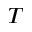Convert formula to latex. <formula><loc_0><loc_0><loc_500><loc_500>T</formula> 